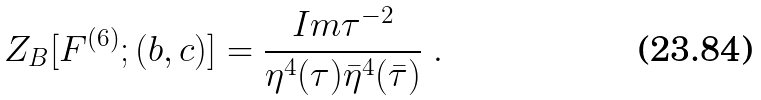<formula> <loc_0><loc_0><loc_500><loc_500>Z _ { B } [ F ^ { ( 6 ) } ; ( { b } , { c } ) ] = \frac { I m \tau ^ { - 2 } } { \eta ^ { 4 } ( \tau ) \bar { \eta } ^ { 4 } ( \bar { \tau } ) } \ .</formula> 